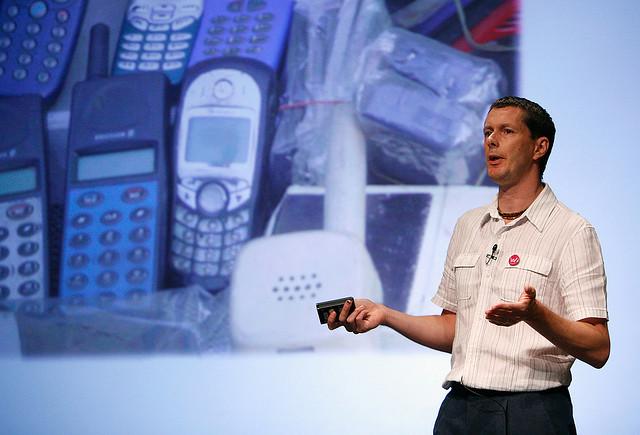Are those iPhones in the background?
Quick response, please. No. Do you think this man is an expert on technology?
Concise answer only. Yes. What is the man holding?
Concise answer only. Cell phone. 